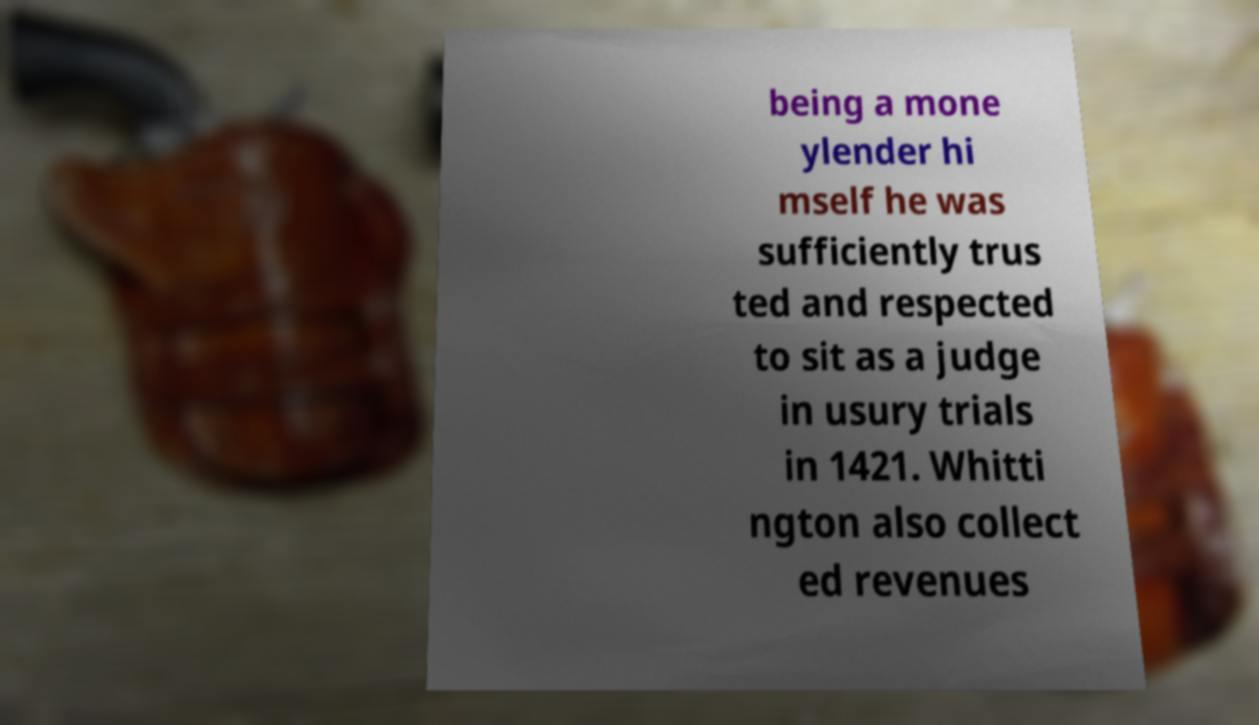Could you assist in decoding the text presented in this image and type it out clearly? being a mone ylender hi mself he was sufficiently trus ted and respected to sit as a judge in usury trials in 1421. Whitti ngton also collect ed revenues 